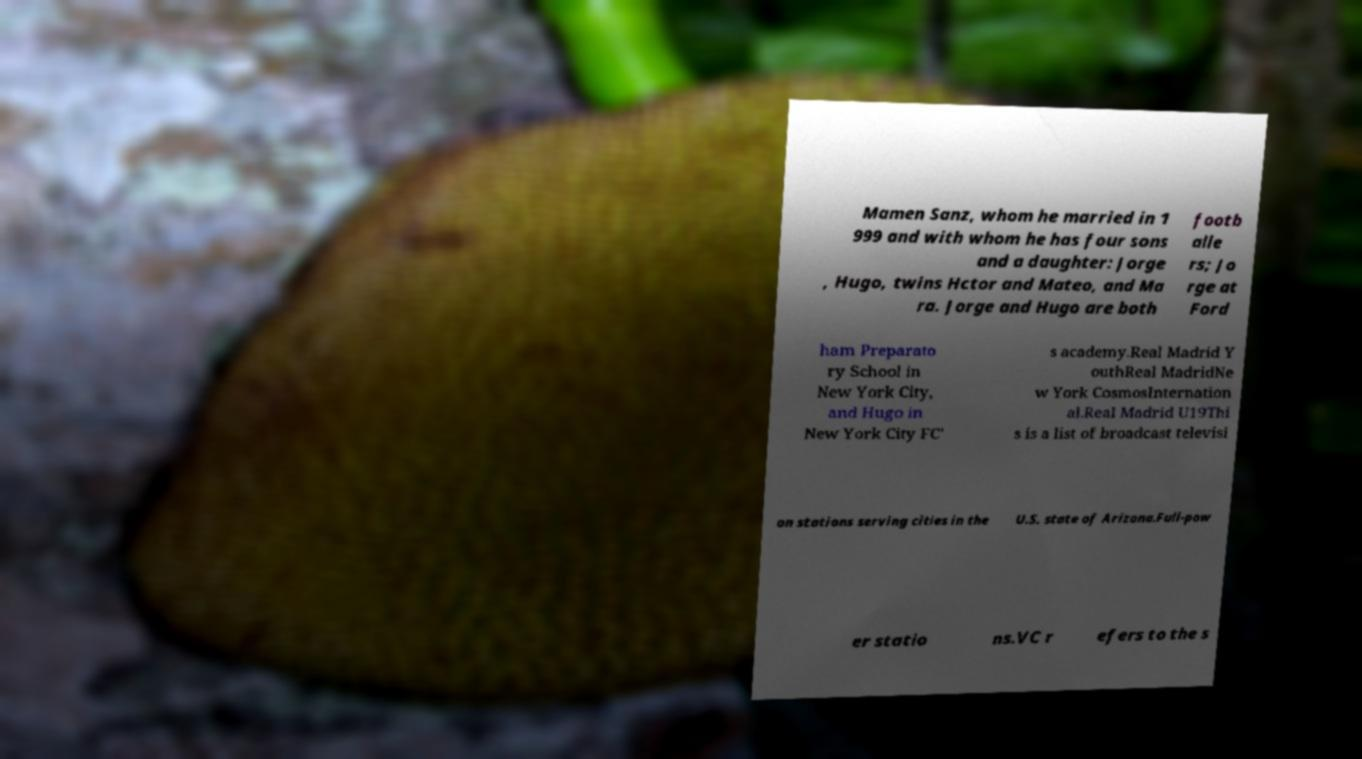What messages or text are displayed in this image? I need them in a readable, typed format. Mamen Sanz, whom he married in 1 999 and with whom he has four sons and a daughter: Jorge , Hugo, twins Hctor and Mateo, and Ma ra. Jorge and Hugo are both footb alle rs; Jo rge at Ford ham Preparato ry School in New York City, and Hugo in New York City FC' s academy.Real Madrid Y outhReal MadridNe w York CosmosInternation al.Real Madrid U19Thi s is a list of broadcast televisi on stations serving cities in the U.S. state of Arizona.Full-pow er statio ns.VC r efers to the s 